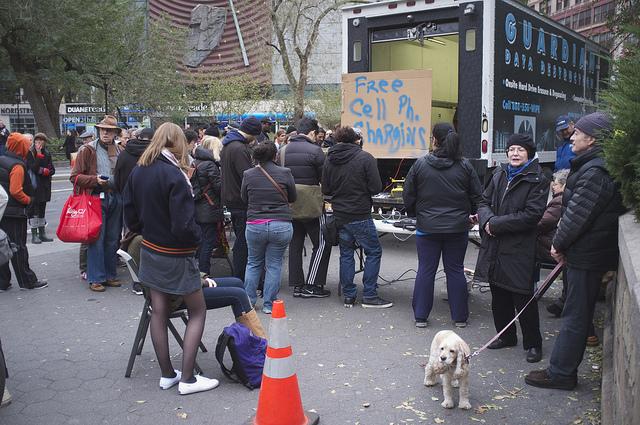Are they giving away free items?
Concise answer only. Yes. What animal is on a leash?
Write a very short answer. Dog. What color jackets are the people primarily wearing?
Short answer required. Black. 